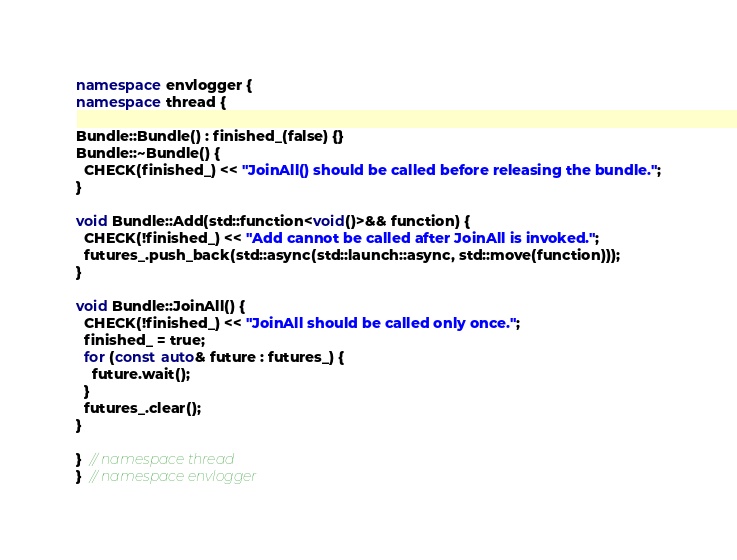Convert code to text. <code><loc_0><loc_0><loc_500><loc_500><_C++_>namespace envlogger {
namespace thread {

Bundle::Bundle() : finished_(false) {}
Bundle::~Bundle() {
  CHECK(finished_) << "JoinAll() should be called before releasing the bundle.";
}

void Bundle::Add(std::function<void()>&& function) {
  CHECK(!finished_) << "Add cannot be called after JoinAll is invoked.";
  futures_.push_back(std::async(std::launch::async, std::move(function)));
}

void Bundle::JoinAll() {
  CHECK(!finished_) << "JoinAll should be called only once.";
  finished_ = true;
  for (const auto& future : futures_) {
    future.wait();
  }
  futures_.clear();
}

}  // namespace thread
}  // namespace envlogger
</code> 